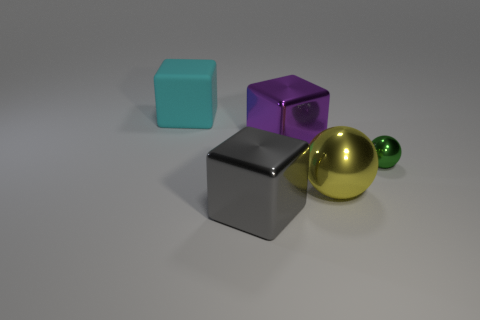Is the number of green shiny balls greater than the number of large red matte cubes?
Your response must be concise. Yes. There is a block behind the big shiny object behind the tiny shiny sphere; how many things are right of it?
Make the answer very short. 4. The cyan rubber object is what shape?
Your response must be concise. Cube. How many other objects are the same material as the big gray thing?
Your response must be concise. 3. Do the yellow object and the rubber block have the same size?
Offer a terse response. Yes. What shape is the big thing that is on the right side of the purple metallic thing?
Offer a very short reply. Sphere. There is a small metallic sphere that is to the right of the block that is in front of the big yellow metallic sphere; what is its color?
Your response must be concise. Green. There is a large metallic thing that is behind the green thing; is it the same shape as the big object that is on the right side of the purple thing?
Provide a short and direct response. No. What shape is the yellow metal thing that is the same size as the purple thing?
Your answer should be compact. Sphere. What color is the tiny thing that is the same material as the gray block?
Offer a very short reply. Green. 